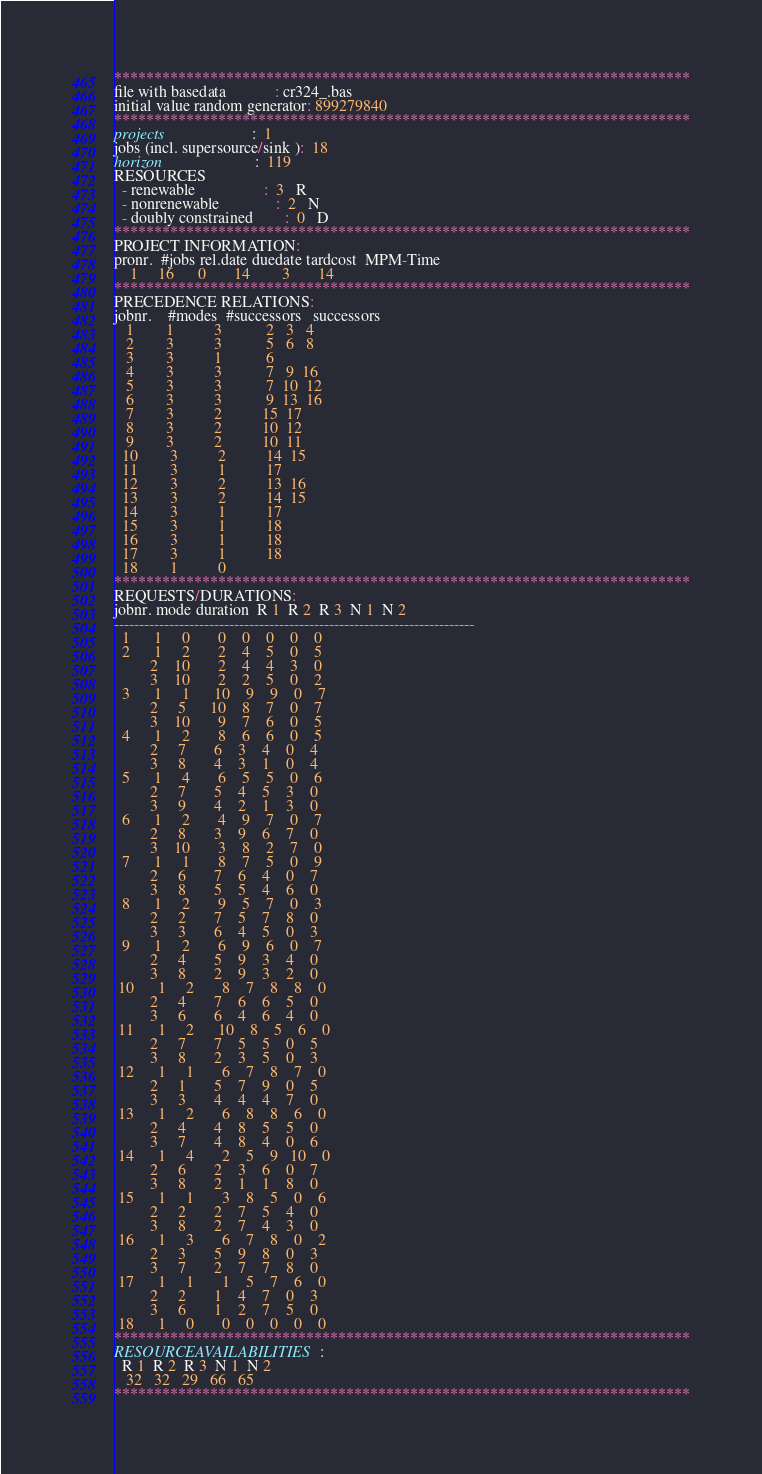Convert code to text. <code><loc_0><loc_0><loc_500><loc_500><_ObjectiveC_>************************************************************************
file with basedata            : cr324_.bas
initial value random generator: 899279840
************************************************************************
projects                      :  1
jobs (incl. supersource/sink ):  18
horizon                       :  119
RESOURCES
  - renewable                 :  3   R
  - nonrenewable              :  2   N
  - doubly constrained        :  0   D
************************************************************************
PROJECT INFORMATION:
pronr.  #jobs rel.date duedate tardcost  MPM-Time
    1     16      0       14        3       14
************************************************************************
PRECEDENCE RELATIONS:
jobnr.    #modes  #successors   successors
   1        1          3           2   3   4
   2        3          3           5   6   8
   3        3          1           6
   4        3          3           7   9  16
   5        3          3           7  10  12
   6        3          3           9  13  16
   7        3          2          15  17
   8        3          2          10  12
   9        3          2          10  11
  10        3          2          14  15
  11        3          1          17
  12        3          2          13  16
  13        3          2          14  15
  14        3          1          17
  15        3          1          18
  16        3          1          18
  17        3          1          18
  18        1          0        
************************************************************************
REQUESTS/DURATIONS:
jobnr. mode duration  R 1  R 2  R 3  N 1  N 2
------------------------------------------------------------------------
  1      1     0       0    0    0    0    0
  2      1     2       2    4    5    0    5
         2    10       2    4    4    3    0
         3    10       2    2    5    0    2
  3      1     1      10    9    9    0    7
         2     5      10    8    7    0    7
         3    10       9    7    6    0    5
  4      1     2       8    6    6    0    5
         2     7       6    3    4    0    4
         3     8       4    3    1    0    4
  5      1     4       6    5    5    0    6
         2     7       5    4    5    3    0
         3     9       4    2    1    3    0
  6      1     2       4    9    7    0    7
         2     8       3    9    6    7    0
         3    10       3    8    2    7    0
  7      1     1       8    7    5    0    9
         2     6       7    6    4    0    7
         3     8       5    5    4    6    0
  8      1     2       9    5    7    0    3
         2     2       7    5    7    8    0
         3     3       6    4    5    0    3
  9      1     2       6    9    6    0    7
         2     4       5    9    3    4    0
         3     8       2    9    3    2    0
 10      1     2       8    7    8    8    0
         2     4       7    6    6    5    0
         3     6       6    4    6    4    0
 11      1     2      10    8    5    6    0
         2     7       7    5    5    0    5
         3     8       2    3    5    0    3
 12      1     1       6    7    8    7    0
         2     1       5    7    9    0    5
         3     3       4    4    4    7    0
 13      1     2       6    8    8    6    0
         2     4       4    8    5    5    0
         3     7       4    8    4    0    6
 14      1     4       2    5    9   10    0
         2     6       2    3    6    0    7
         3     8       2    1    1    8    0
 15      1     1       3    8    5    0    6
         2     2       2    7    5    4    0
         3     8       2    7    4    3    0
 16      1     3       6    7    8    0    2
         2     3       5    9    8    0    3
         3     7       2    7    7    8    0
 17      1     1       1    5    7    6    0
         2     2       1    4    7    0    3
         3     6       1    2    7    5    0
 18      1     0       0    0    0    0    0
************************************************************************
RESOURCEAVAILABILITIES:
  R 1  R 2  R 3  N 1  N 2
   32   32   29   66   65
************************************************************************
</code> 